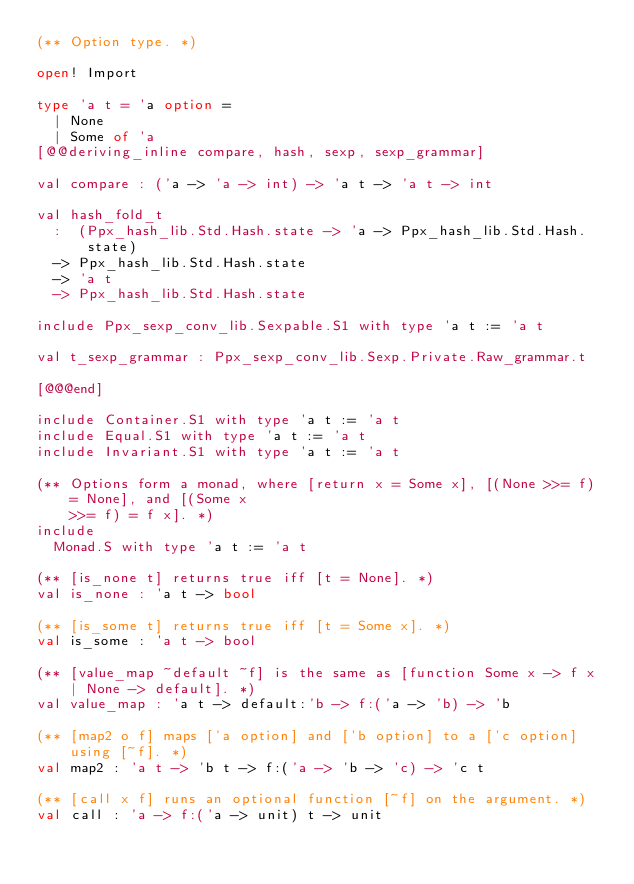<code> <loc_0><loc_0><loc_500><loc_500><_OCaml_>(** Option type. *)

open! Import

type 'a t = 'a option =
  | None
  | Some of 'a
[@@deriving_inline compare, hash, sexp, sexp_grammar]

val compare : ('a -> 'a -> int) -> 'a t -> 'a t -> int

val hash_fold_t
  :  (Ppx_hash_lib.Std.Hash.state -> 'a -> Ppx_hash_lib.Std.Hash.state)
  -> Ppx_hash_lib.Std.Hash.state
  -> 'a t
  -> Ppx_hash_lib.Std.Hash.state

include Ppx_sexp_conv_lib.Sexpable.S1 with type 'a t := 'a t

val t_sexp_grammar : Ppx_sexp_conv_lib.Sexp.Private.Raw_grammar.t

[@@@end]

include Container.S1 with type 'a t := 'a t
include Equal.S1 with type 'a t := 'a t
include Invariant.S1 with type 'a t := 'a t

(** Options form a monad, where [return x = Some x], [(None >>= f) = None], and [(Some x
    >>= f) = f x]. *)
include
  Monad.S with type 'a t := 'a t

(** [is_none t] returns true iff [t = None]. *)
val is_none : 'a t -> bool

(** [is_some t] returns true iff [t = Some x]. *)
val is_some : 'a t -> bool

(** [value_map ~default ~f] is the same as [function Some x -> f x | None -> default]. *)
val value_map : 'a t -> default:'b -> f:('a -> 'b) -> 'b

(** [map2 o f] maps ['a option] and ['b option] to a ['c option] using [~f]. *)
val map2 : 'a t -> 'b t -> f:('a -> 'b -> 'c) -> 'c t

(** [call x f] runs an optional function [~f] on the argument. *)
val call : 'a -> f:('a -> unit) t -> unit
</code> 